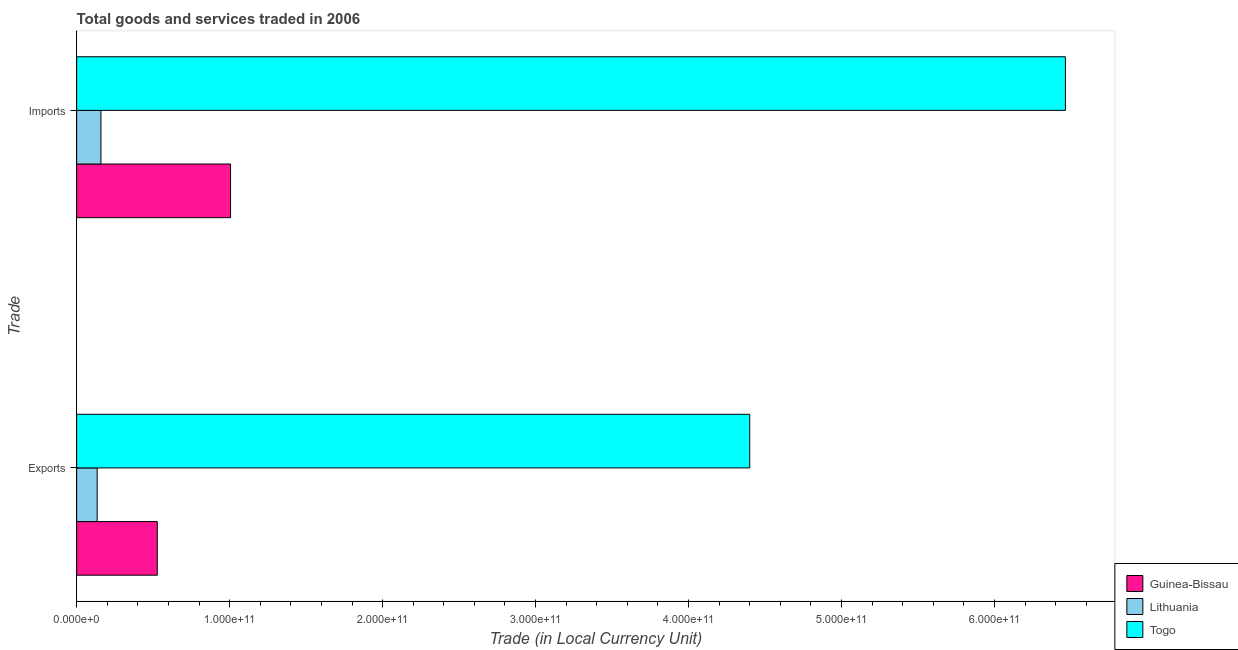How many different coloured bars are there?
Offer a terse response. 3. How many groups of bars are there?
Your response must be concise. 2. Are the number of bars per tick equal to the number of legend labels?
Your response must be concise. Yes. How many bars are there on the 1st tick from the top?
Make the answer very short. 3. What is the label of the 1st group of bars from the top?
Offer a terse response. Imports. What is the export of goods and services in Guinea-Bissau?
Give a very brief answer. 5.27e+1. Across all countries, what is the maximum imports of goods and services?
Give a very brief answer. 6.46e+11. Across all countries, what is the minimum export of goods and services?
Give a very brief answer. 1.34e+1. In which country was the imports of goods and services maximum?
Give a very brief answer. Togo. In which country was the export of goods and services minimum?
Provide a succinct answer. Lithuania. What is the total export of goods and services in the graph?
Offer a terse response. 5.06e+11. What is the difference between the imports of goods and services in Togo and that in Guinea-Bissau?
Your answer should be compact. 5.46e+11. What is the difference between the imports of goods and services in Guinea-Bissau and the export of goods and services in Togo?
Keep it short and to the point. -3.39e+11. What is the average imports of goods and services per country?
Provide a short and direct response. 2.54e+11. What is the difference between the export of goods and services and imports of goods and services in Guinea-Bissau?
Your answer should be very brief. -4.79e+1. What is the ratio of the imports of goods and services in Lithuania to that in Togo?
Keep it short and to the point. 0.02. In how many countries, is the imports of goods and services greater than the average imports of goods and services taken over all countries?
Provide a succinct answer. 1. What does the 3rd bar from the top in Exports represents?
Your answer should be very brief. Guinea-Bissau. What does the 1st bar from the bottom in Imports represents?
Your answer should be compact. Guinea-Bissau. How many bars are there?
Your answer should be very brief. 6. Are all the bars in the graph horizontal?
Your answer should be very brief. Yes. How many countries are there in the graph?
Offer a very short reply. 3. What is the difference between two consecutive major ticks on the X-axis?
Your response must be concise. 1.00e+11. Are the values on the major ticks of X-axis written in scientific E-notation?
Provide a short and direct response. Yes. Where does the legend appear in the graph?
Offer a terse response. Bottom right. How are the legend labels stacked?
Your response must be concise. Vertical. What is the title of the graph?
Give a very brief answer. Total goods and services traded in 2006. What is the label or title of the X-axis?
Keep it short and to the point. Trade (in Local Currency Unit). What is the label or title of the Y-axis?
Your response must be concise. Trade. What is the Trade (in Local Currency Unit) in Guinea-Bissau in Exports?
Ensure brevity in your answer.  5.27e+1. What is the Trade (in Local Currency Unit) of Lithuania in Exports?
Offer a terse response. 1.34e+1. What is the Trade (in Local Currency Unit) of Togo in Exports?
Offer a very short reply. 4.40e+11. What is the Trade (in Local Currency Unit) in Guinea-Bissau in Imports?
Keep it short and to the point. 1.01e+11. What is the Trade (in Local Currency Unit) in Lithuania in Imports?
Your answer should be compact. 1.59e+1. What is the Trade (in Local Currency Unit) in Togo in Imports?
Ensure brevity in your answer.  6.46e+11. Across all Trade, what is the maximum Trade (in Local Currency Unit) in Guinea-Bissau?
Offer a very short reply. 1.01e+11. Across all Trade, what is the maximum Trade (in Local Currency Unit) of Lithuania?
Give a very brief answer. 1.59e+1. Across all Trade, what is the maximum Trade (in Local Currency Unit) in Togo?
Keep it short and to the point. 6.46e+11. Across all Trade, what is the minimum Trade (in Local Currency Unit) of Guinea-Bissau?
Your answer should be very brief. 5.27e+1. Across all Trade, what is the minimum Trade (in Local Currency Unit) of Lithuania?
Offer a terse response. 1.34e+1. Across all Trade, what is the minimum Trade (in Local Currency Unit) in Togo?
Your response must be concise. 4.40e+11. What is the total Trade (in Local Currency Unit) in Guinea-Bissau in the graph?
Provide a short and direct response. 1.53e+11. What is the total Trade (in Local Currency Unit) of Lithuania in the graph?
Offer a very short reply. 2.93e+1. What is the total Trade (in Local Currency Unit) of Togo in the graph?
Offer a terse response. 1.09e+12. What is the difference between the Trade (in Local Currency Unit) in Guinea-Bissau in Exports and that in Imports?
Provide a short and direct response. -4.79e+1. What is the difference between the Trade (in Local Currency Unit) in Lithuania in Exports and that in Imports?
Your answer should be compact. -2.46e+09. What is the difference between the Trade (in Local Currency Unit) in Togo in Exports and that in Imports?
Your response must be concise. -2.06e+11. What is the difference between the Trade (in Local Currency Unit) in Guinea-Bissau in Exports and the Trade (in Local Currency Unit) in Lithuania in Imports?
Offer a very short reply. 3.68e+1. What is the difference between the Trade (in Local Currency Unit) in Guinea-Bissau in Exports and the Trade (in Local Currency Unit) in Togo in Imports?
Keep it short and to the point. -5.94e+11. What is the difference between the Trade (in Local Currency Unit) of Lithuania in Exports and the Trade (in Local Currency Unit) of Togo in Imports?
Your response must be concise. -6.33e+11. What is the average Trade (in Local Currency Unit) in Guinea-Bissau per Trade?
Ensure brevity in your answer.  7.67e+1. What is the average Trade (in Local Currency Unit) of Lithuania per Trade?
Make the answer very short. 1.46e+1. What is the average Trade (in Local Currency Unit) of Togo per Trade?
Your answer should be compact. 5.43e+11. What is the difference between the Trade (in Local Currency Unit) in Guinea-Bissau and Trade (in Local Currency Unit) in Lithuania in Exports?
Offer a terse response. 3.93e+1. What is the difference between the Trade (in Local Currency Unit) in Guinea-Bissau and Trade (in Local Currency Unit) in Togo in Exports?
Offer a very short reply. -3.87e+11. What is the difference between the Trade (in Local Currency Unit) in Lithuania and Trade (in Local Currency Unit) in Togo in Exports?
Provide a succinct answer. -4.27e+11. What is the difference between the Trade (in Local Currency Unit) in Guinea-Bissau and Trade (in Local Currency Unit) in Lithuania in Imports?
Provide a succinct answer. 8.47e+1. What is the difference between the Trade (in Local Currency Unit) of Guinea-Bissau and Trade (in Local Currency Unit) of Togo in Imports?
Offer a very short reply. -5.46e+11. What is the difference between the Trade (in Local Currency Unit) in Lithuania and Trade (in Local Currency Unit) in Togo in Imports?
Ensure brevity in your answer.  -6.30e+11. What is the ratio of the Trade (in Local Currency Unit) in Guinea-Bissau in Exports to that in Imports?
Offer a terse response. 0.52. What is the ratio of the Trade (in Local Currency Unit) of Lithuania in Exports to that in Imports?
Give a very brief answer. 0.85. What is the ratio of the Trade (in Local Currency Unit) of Togo in Exports to that in Imports?
Make the answer very short. 0.68. What is the difference between the highest and the second highest Trade (in Local Currency Unit) of Guinea-Bissau?
Your answer should be compact. 4.79e+1. What is the difference between the highest and the second highest Trade (in Local Currency Unit) in Lithuania?
Provide a short and direct response. 2.46e+09. What is the difference between the highest and the second highest Trade (in Local Currency Unit) of Togo?
Provide a short and direct response. 2.06e+11. What is the difference between the highest and the lowest Trade (in Local Currency Unit) of Guinea-Bissau?
Your response must be concise. 4.79e+1. What is the difference between the highest and the lowest Trade (in Local Currency Unit) in Lithuania?
Keep it short and to the point. 2.46e+09. What is the difference between the highest and the lowest Trade (in Local Currency Unit) in Togo?
Your answer should be very brief. 2.06e+11. 